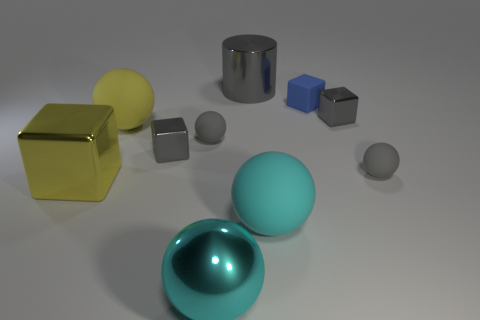Subtract all tiny matte balls. How many balls are left? 3 Subtract all yellow balls. How many balls are left? 4 Subtract all purple cylinders. How many gray cubes are left? 2 Subtract all cylinders. How many objects are left? 9 Subtract all tiny brown rubber things. Subtract all big yellow shiny cubes. How many objects are left? 9 Add 4 big cyan things. How many big cyan things are left? 6 Add 6 tiny rubber spheres. How many tiny rubber spheres exist? 8 Subtract 1 yellow blocks. How many objects are left? 9 Subtract 2 spheres. How many spheres are left? 3 Subtract all yellow balls. Subtract all purple cubes. How many balls are left? 4 